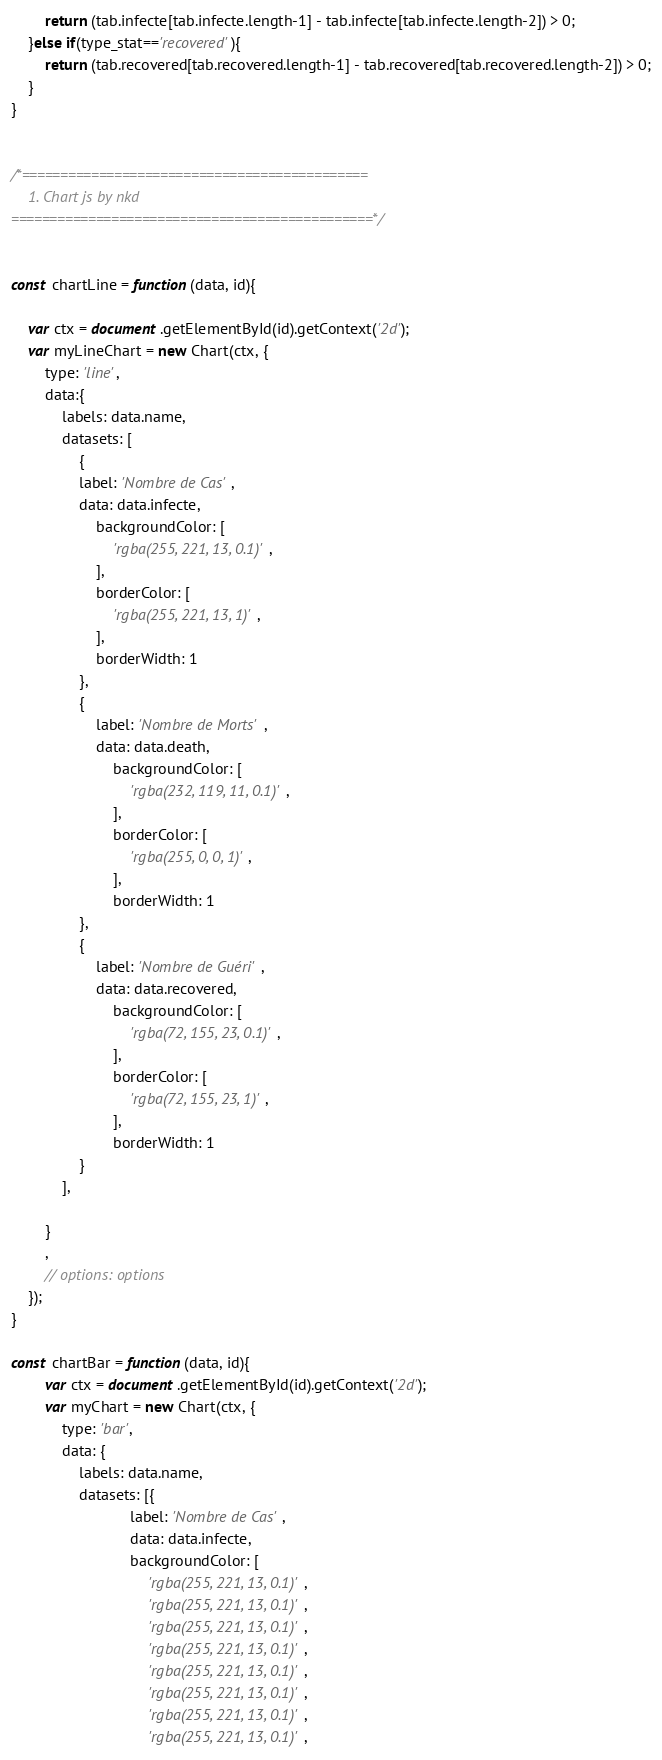<code> <loc_0><loc_0><loc_500><loc_500><_JavaScript_>        return (tab.infecte[tab.infecte.length-1] - tab.infecte[tab.infecte.length-2]) > 0;
    }else if(type_stat=='recovered'){
        return (tab.recovered[tab.recovered.length-1] - tab.recovered[tab.recovered.length-2]) > 0;
    }
}


/*=============================================
	1. Chart js by nkd
===============================================*/ 


const chartLine = function(data, id){

    var ctx = document.getElementById(id).getContext('2d');
    var myLineChart = new Chart(ctx, {
        type: 'line',
        data:{ 
            labels: data.name,
            datasets: [
                {
                label: 'Nombre de Cas',
                data: data.infecte,
                    backgroundColor: [
                        'rgba(255, 221, 13, 0.1)',
                    ],
                    borderColor: [
                        'rgba(255, 221, 13, 1)',
                    ],
                    borderWidth: 1
                },
                {
                    label: 'Nombre de Morts',
                    data: data.death,
                        backgroundColor: [
                            'rgba(232, 119, 11, 0.1)',
                        ],
                        borderColor: [
                            'rgba(255, 0, 0, 1)',
                        ],
                        borderWidth: 1
                },
                {
                    label: 'Nombre de Guéri',
                    data: data.recovered,
                        backgroundColor: [
                            'rgba(72, 155, 23, 0.1)',
                        ],
                        borderColor: [
                            'rgba(72, 155, 23, 1)',
                        ],
                        borderWidth: 1
                }
            ],
            
        }
        ,
        // options: options
    });
}

const chartBar = function(data, id){
        var ctx = document.getElementById(id).getContext('2d');
        var myChart = new Chart(ctx, {
            type: 'bar',
            data: {
                labels: data.name,
                datasets: [{
                            label: 'Nombre de Cas',
                            data: data.infecte,
                            backgroundColor: [
                                'rgba(255, 221, 13, 0.1)',
                                'rgba(255, 221, 13, 0.1)',
                                'rgba(255, 221, 13, 0.1)',
                                'rgba(255, 221, 13, 0.1)',
                                'rgba(255, 221, 13, 0.1)',
                                'rgba(255, 221, 13, 0.1)',
                                'rgba(255, 221, 13, 0.1)',
                                'rgba(255, 221, 13, 0.1)',</code> 